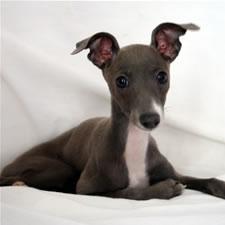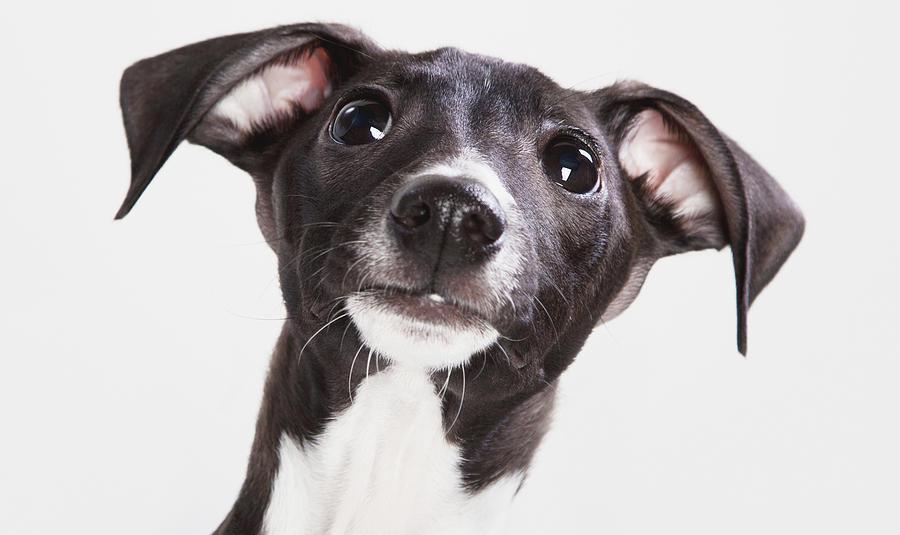The first image is the image on the left, the second image is the image on the right. Examine the images to the left and right. Is the description "The full body of a dog facing right is on the left image." accurate? Answer yes or no. No. 